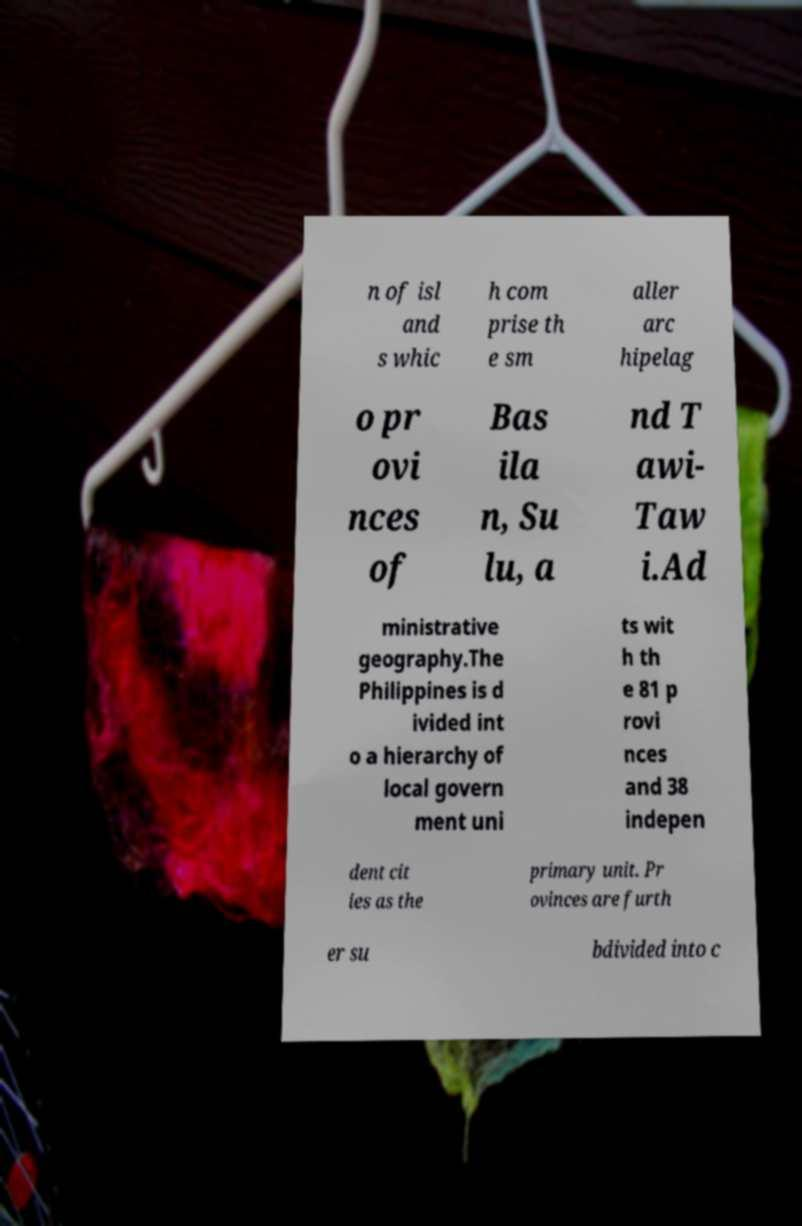What messages or text are displayed in this image? I need them in a readable, typed format. n of isl and s whic h com prise th e sm aller arc hipelag o pr ovi nces of Bas ila n, Su lu, a nd T awi- Taw i.Ad ministrative geography.The Philippines is d ivided int o a hierarchy of local govern ment uni ts wit h th e 81 p rovi nces and 38 indepen dent cit ies as the primary unit. Pr ovinces are furth er su bdivided into c 